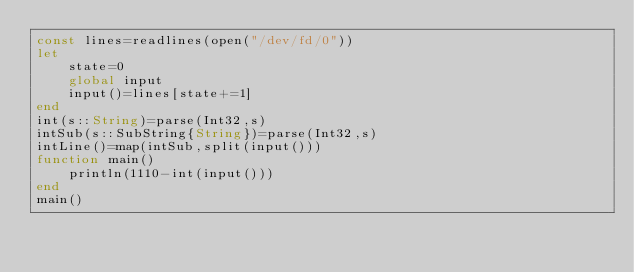<code> <loc_0><loc_0><loc_500><loc_500><_Julia_>const lines=readlines(open("/dev/fd/0"))
let
    state=0
    global input
    input()=lines[state+=1]
end
int(s::String)=parse(Int32,s)
intSub(s::SubString{String})=parse(Int32,s)
intLine()=map(intSub,split(input()))
function main()
    println(1110-int(input()))
end
main()</code> 